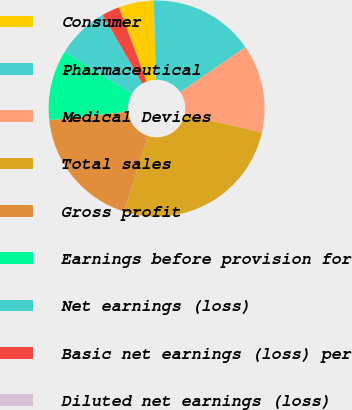Convert chart. <chart><loc_0><loc_0><loc_500><loc_500><pie_chart><fcel>Consumer<fcel>Pharmaceutical<fcel>Medical Devices<fcel>Total sales<fcel>Gross profit<fcel>Earnings before provision for<fcel>Net earnings (loss)<fcel>Basic net earnings (loss) per<fcel>Diluted net earnings (loss)<nl><fcel>5.26%<fcel>15.79%<fcel>13.16%<fcel>26.31%<fcel>18.42%<fcel>10.53%<fcel>7.9%<fcel>2.63%<fcel>0.0%<nl></chart> 